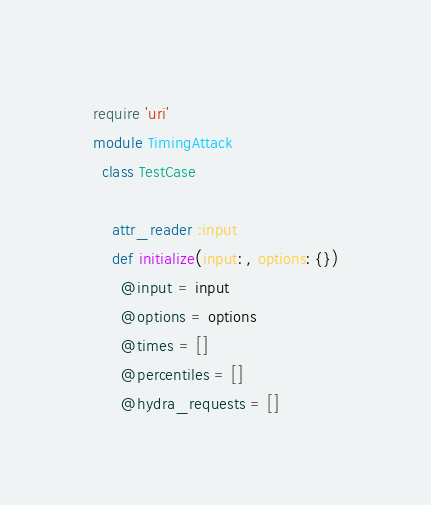<code> <loc_0><loc_0><loc_500><loc_500><_Ruby_>require 'uri'
module TimingAttack
  class TestCase

    attr_reader :input
    def initialize(input: , options: {})
      @input = input
      @options = options
      @times = []
      @percentiles = []
      @hydra_requests = []</code> 